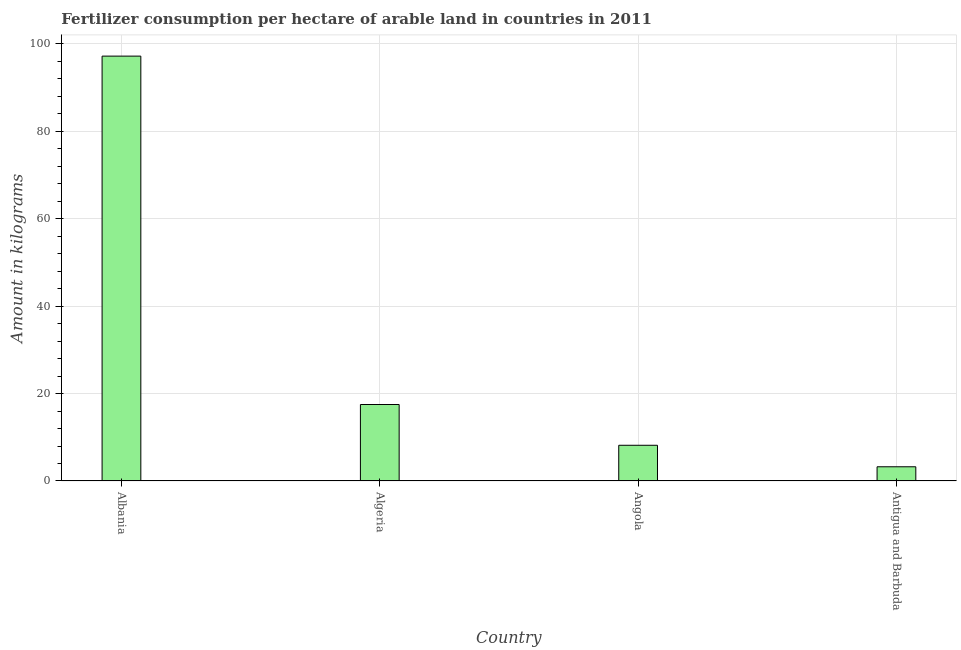Does the graph contain any zero values?
Offer a very short reply. No. Does the graph contain grids?
Your response must be concise. Yes. What is the title of the graph?
Your response must be concise. Fertilizer consumption per hectare of arable land in countries in 2011 . What is the label or title of the X-axis?
Provide a short and direct response. Country. What is the label or title of the Y-axis?
Provide a short and direct response. Amount in kilograms. What is the amount of fertilizer consumption in Angola?
Provide a succinct answer. 8.17. Across all countries, what is the maximum amount of fertilizer consumption?
Ensure brevity in your answer.  97.14. In which country was the amount of fertilizer consumption maximum?
Offer a very short reply. Albania. In which country was the amount of fertilizer consumption minimum?
Offer a terse response. Antigua and Barbuda. What is the sum of the amount of fertilizer consumption?
Your response must be concise. 126.04. What is the difference between the amount of fertilizer consumption in Albania and Algeria?
Your answer should be compact. 79.65. What is the average amount of fertilizer consumption per country?
Your answer should be compact. 31.51. What is the median amount of fertilizer consumption?
Make the answer very short. 12.83. What is the ratio of the amount of fertilizer consumption in Angola to that in Antigua and Barbuda?
Offer a terse response. 2.51. Is the amount of fertilizer consumption in Algeria less than that in Angola?
Offer a terse response. No. Is the difference between the amount of fertilizer consumption in Albania and Antigua and Barbuda greater than the difference between any two countries?
Provide a succinct answer. Yes. What is the difference between the highest and the second highest amount of fertilizer consumption?
Your answer should be very brief. 79.65. Is the sum of the amount of fertilizer consumption in Angola and Antigua and Barbuda greater than the maximum amount of fertilizer consumption across all countries?
Give a very brief answer. No. What is the difference between the highest and the lowest amount of fertilizer consumption?
Ensure brevity in your answer.  93.89. In how many countries, is the amount of fertilizer consumption greater than the average amount of fertilizer consumption taken over all countries?
Keep it short and to the point. 1. Are all the bars in the graph horizontal?
Provide a succinct answer. No. Are the values on the major ticks of Y-axis written in scientific E-notation?
Provide a succinct answer. No. What is the Amount in kilograms in Albania?
Provide a succinct answer. 97.14. What is the Amount in kilograms of Algeria?
Keep it short and to the point. 17.49. What is the Amount in kilograms in Angola?
Provide a succinct answer. 8.17. What is the difference between the Amount in kilograms in Albania and Algeria?
Offer a terse response. 79.65. What is the difference between the Amount in kilograms in Albania and Angola?
Offer a terse response. 88.97. What is the difference between the Amount in kilograms in Albania and Antigua and Barbuda?
Offer a very short reply. 93.89. What is the difference between the Amount in kilograms in Algeria and Angola?
Provide a succinct answer. 9.32. What is the difference between the Amount in kilograms in Algeria and Antigua and Barbuda?
Give a very brief answer. 14.24. What is the difference between the Amount in kilograms in Angola and Antigua and Barbuda?
Provide a short and direct response. 4.92. What is the ratio of the Amount in kilograms in Albania to that in Algeria?
Offer a very short reply. 5.55. What is the ratio of the Amount in kilograms in Albania to that in Angola?
Your answer should be compact. 11.89. What is the ratio of the Amount in kilograms in Albania to that in Antigua and Barbuda?
Make the answer very short. 29.89. What is the ratio of the Amount in kilograms in Algeria to that in Angola?
Provide a short and direct response. 2.14. What is the ratio of the Amount in kilograms in Algeria to that in Antigua and Barbuda?
Offer a very short reply. 5.38. What is the ratio of the Amount in kilograms in Angola to that in Antigua and Barbuda?
Your answer should be compact. 2.51. 